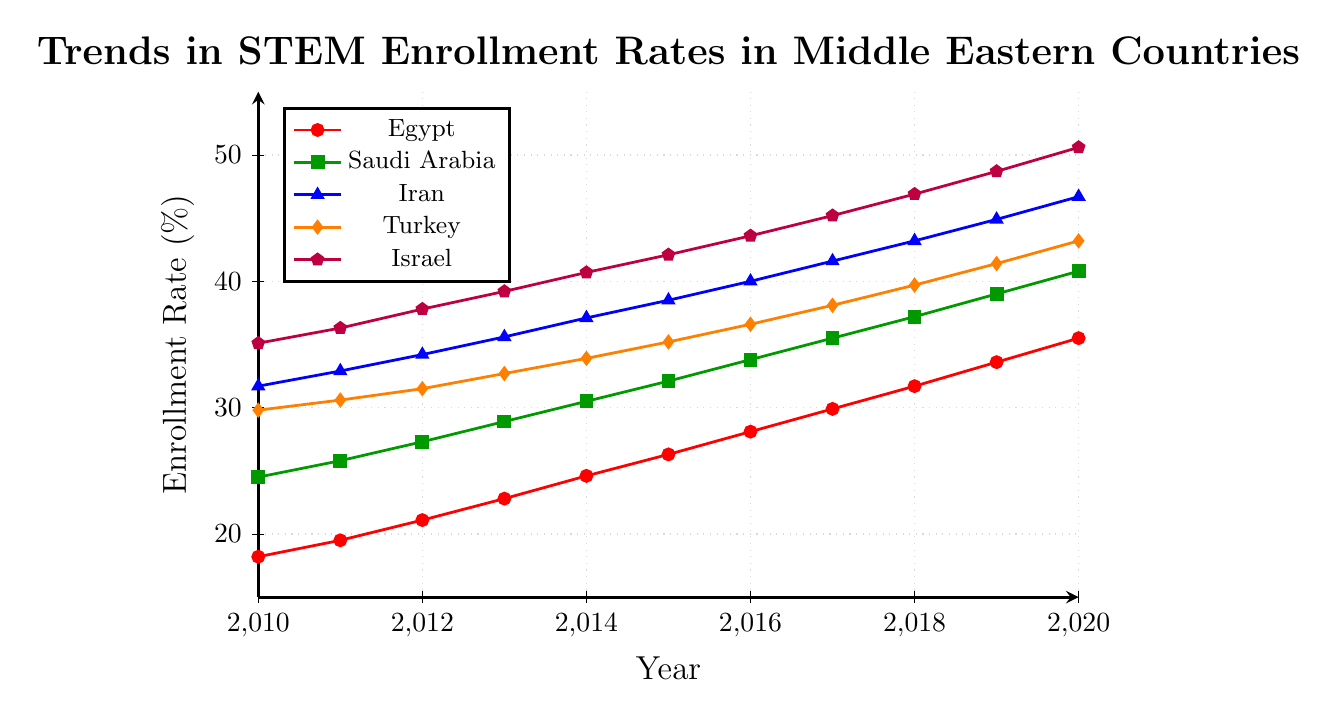Which country had the highest STEM enrollment rate in 2010? Look at the data points for 2010 on the line chart. The country with the highest data point for this year is Israel.
Answer: Israel Which country experienced the greatest increase in STEM enrollment rate from 2010 to 2020? Calculate the difference in enrollment rates between 2020 and 2010 for each country. Israel increased from 35.1% in 2010 to 50.6% in 2020, which is a 15.5% increase, the highest among all countries.
Answer: Israel In what year did Turkey's STEM enrollment rate surpass 40%? Track the progress of Turkey’s enrollment rate on the line representing Turkey. It exceeds 40% in 2019.
Answer: 2019 Compare the enrollment rate trends between Saudi Arabia and Egypt from 2010 to 2020. Which country had a more consistent increase? Compare the slopes of the lines representing Saudi Arabia and Egypt. Both lines show a consistent increase, but Saudi Arabia has a slightly steadier upward trend.
Answer: Saudi Arabia What was the average STEM enrollment rate for Iran in the years 2015 to 2017 inclusive? Sum Iran's enrollment rates for 2015 (38.5%), 2016 (40.0%), and 2017 (41.6%) and divide by three to find the average. (38.5 + 40.0 + 41.6) / 3 = 40.03%
Answer: 40.03% By how much did Egypt's STEM enrollment rate increase from 2013 to 2014? Calculate the difference between enrollment rates in 2014 and 2013 for Egypt: 24.6% - 22.8% = 1.8%
Answer: 1.8% Which country had the smallest change in STEM enrollment rate from 2016 to 2020? Find the difference for each country between the years 2016 and 2020. Saudi Arabia increased from 33.8% to 40.8%, giving a difference of 7%, which is the smallest among all countries.
Answer: Saudi Arabia What is the enrollment rate difference between Israel and Egypt in 2020? Subtract Egypt's 2020 enrollment rate from Israel's: 50.6% - 35.5% = 15.1%
Answer: 15.1% Among the five countries, which one had the second-highest enrollment rate in 2012? Compare the 2012 enrollment rates of all countries. Iran had the second-highest rate at 34.2%, after Israel.
Answer: Iran 